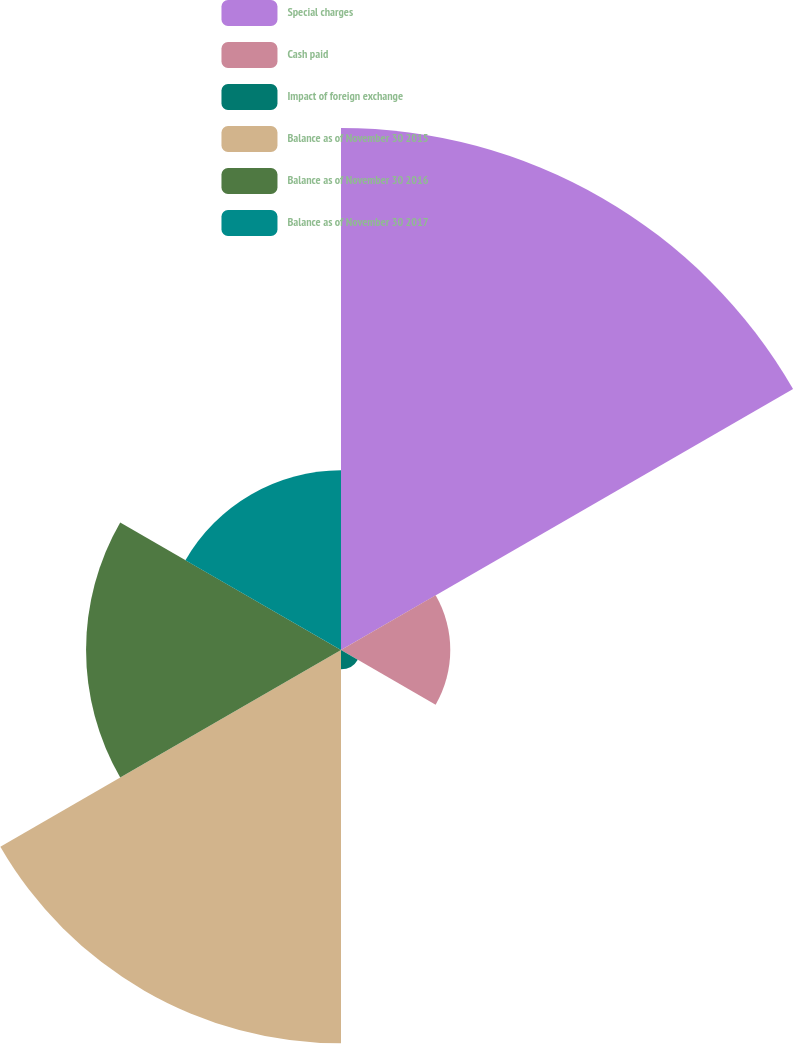<chart> <loc_0><loc_0><loc_500><loc_500><pie_chart><fcel>Special charges<fcel>Cash paid<fcel>Impact of foreign exchange<fcel>Balance as of November 30 2015<fcel>Balance as of November 30 2016<fcel>Balance as of November 30 2017<nl><fcel>35.3%<fcel>7.39%<fcel>1.31%<fcel>26.6%<fcel>17.24%<fcel>12.15%<nl></chart> 